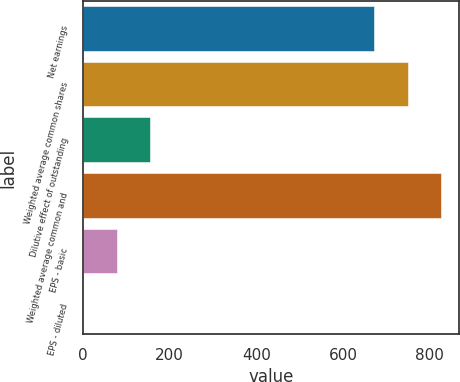Convert chart to OTSL. <chart><loc_0><loc_0><loc_500><loc_500><bar_chart><fcel>Net earnings<fcel>Weighted average common shares<fcel>Dilutive effect of outstanding<fcel>Weighted average common and<fcel>EPS - basic<fcel>EPS - diluted<nl><fcel>672.6<fcel>749.8<fcel>154.71<fcel>826.72<fcel>77.79<fcel>0.87<nl></chart> 